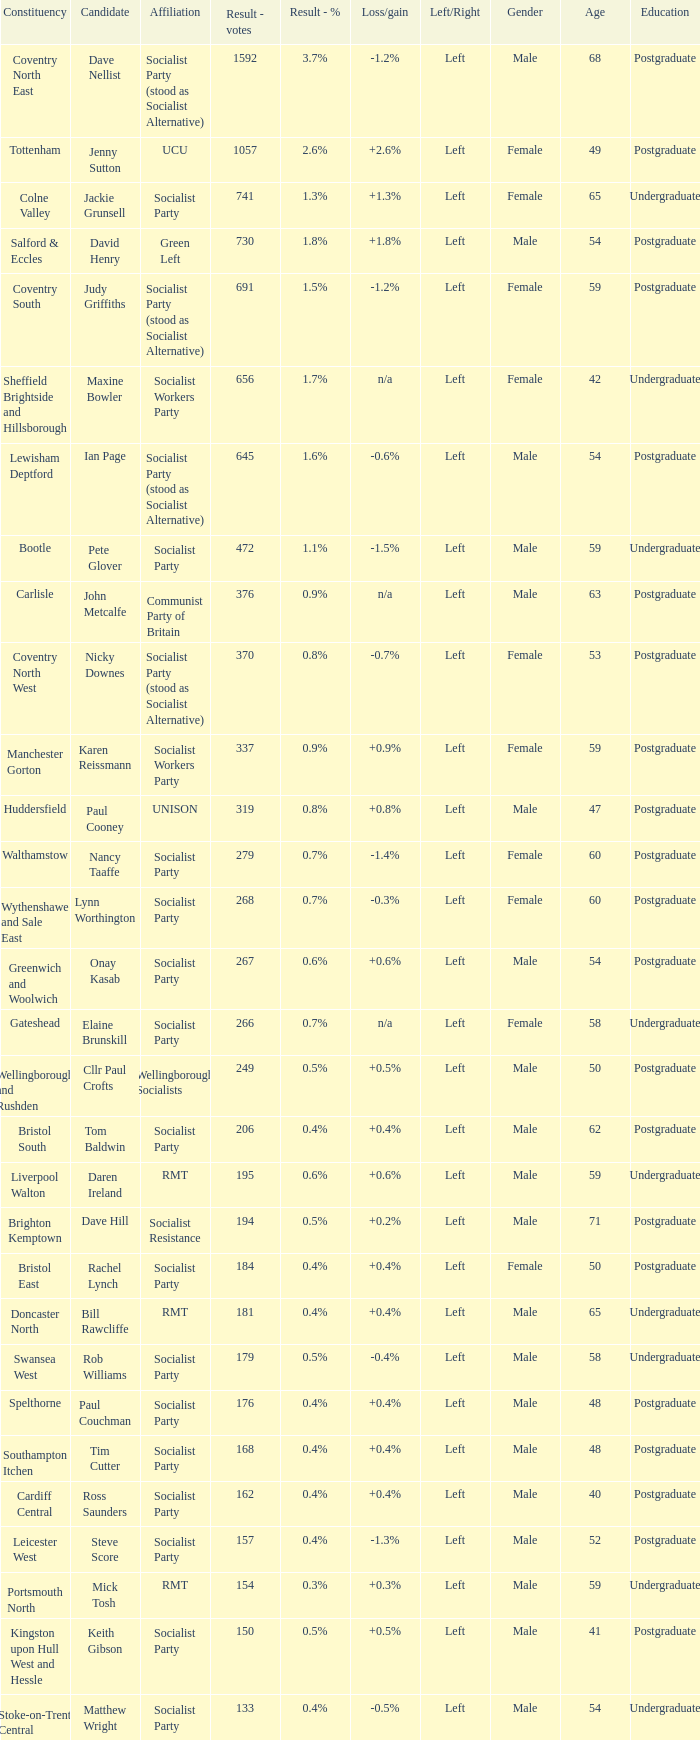How many values for constituency for the vote result of 162? 1.0. 